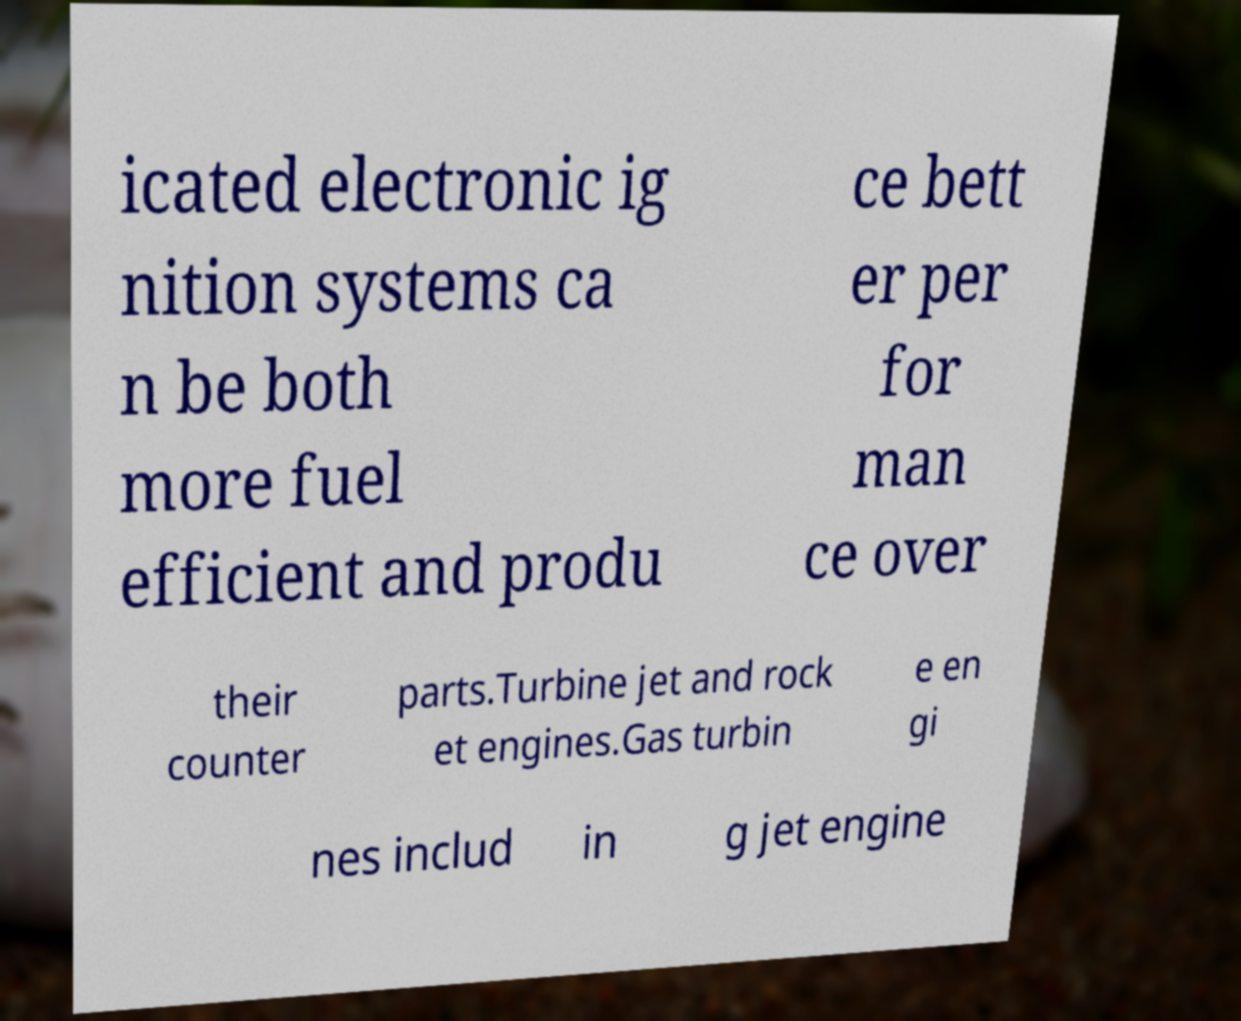Please read and relay the text visible in this image. What does it say? icated electronic ig nition systems ca n be both more fuel efficient and produ ce bett er per for man ce over their counter parts.Turbine jet and rock et engines.Gas turbin e en gi nes includ in g jet engine 